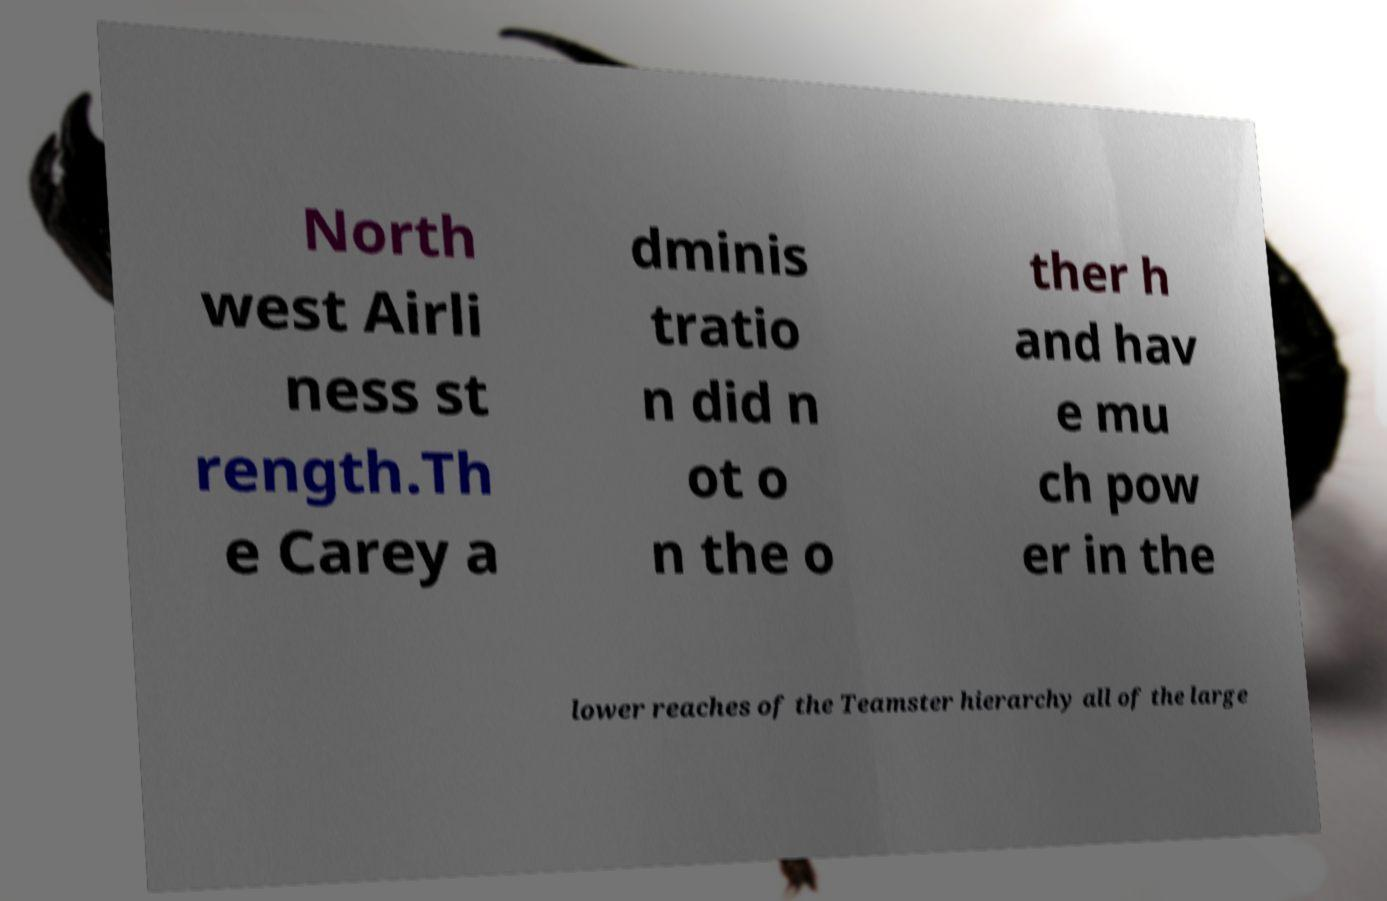There's text embedded in this image that I need extracted. Can you transcribe it verbatim? North west Airli ness st rength.Th e Carey a dminis tratio n did n ot o n the o ther h and hav e mu ch pow er in the lower reaches of the Teamster hierarchy all of the large 